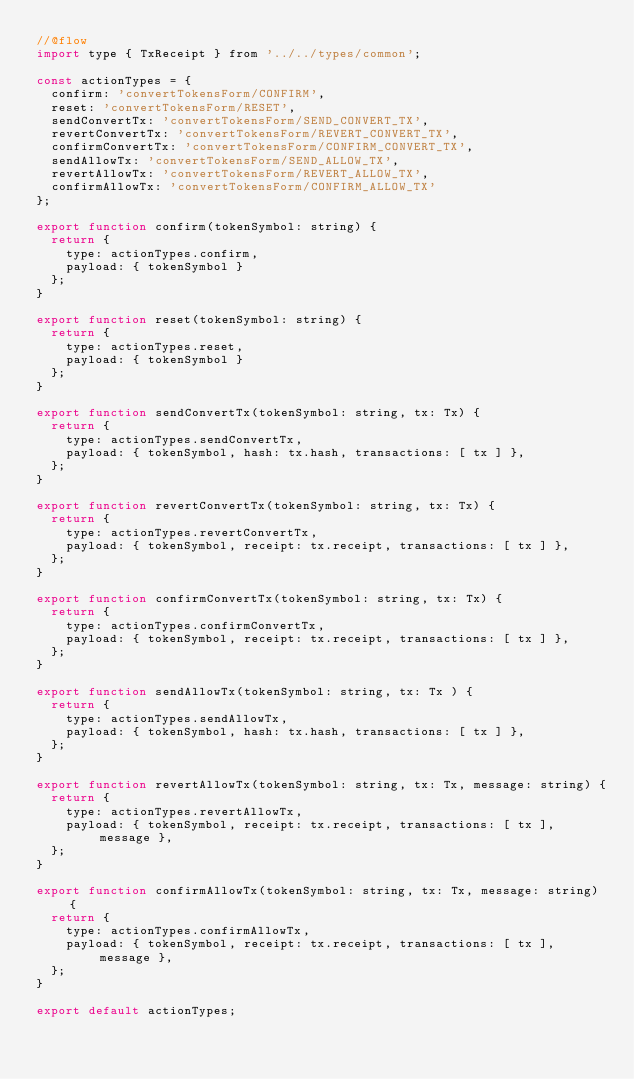<code> <loc_0><loc_0><loc_500><loc_500><_JavaScript_>//@flow
import type { TxReceipt } from '../../types/common';

const actionTypes = {
  confirm: 'convertTokensForm/CONFIRM',
  reset: 'convertTokensForm/RESET',
  sendConvertTx: 'convertTokensForm/SEND_CONVERT_TX',
  revertConvertTx: 'convertTokensForm/REVERT_CONVERT_TX',
  confirmConvertTx: 'convertTokensForm/CONFIRM_CONVERT_TX',
  sendAllowTx: 'convertTokensForm/SEND_ALLOW_TX',
  revertAllowTx: 'convertTokensForm/REVERT_ALLOW_TX',
  confirmAllowTx: 'convertTokensForm/CONFIRM_ALLOW_TX'
};

export function confirm(tokenSymbol: string) {
  return {
    type: actionTypes.confirm,
    payload: { tokenSymbol }
  };
}

export function reset(tokenSymbol: string) {
  return {
    type: actionTypes.reset,
    payload: { tokenSymbol }
  };
}

export function sendConvertTx(tokenSymbol: string, tx: Tx) {
  return {
    type: actionTypes.sendConvertTx,
    payload: { tokenSymbol, hash: tx.hash, transactions: [ tx ] },
  };
}

export function revertConvertTx(tokenSymbol: string, tx: Tx) {
  return {
    type: actionTypes.revertConvertTx,
    payload: { tokenSymbol, receipt: tx.receipt, transactions: [ tx ] },
  };
}

export function confirmConvertTx(tokenSymbol: string, tx: Tx) {
  return {
    type: actionTypes.confirmConvertTx,
    payload: { tokenSymbol, receipt: tx.receipt, transactions: [ tx ] },
  };
}

export function sendAllowTx(tokenSymbol: string, tx: Tx ) {
  return {
    type: actionTypes.sendAllowTx,
    payload: { tokenSymbol, hash: tx.hash, transactions: [ tx ] },
  };
}

export function revertAllowTx(tokenSymbol: string, tx: Tx, message: string) {
  return {
    type: actionTypes.revertAllowTx,
    payload: { tokenSymbol, receipt: tx.receipt, transactions: [ tx ], message },
  };
}

export function confirmAllowTx(tokenSymbol: string, tx: Tx, message: string) {
  return {
    type: actionTypes.confirmAllowTx,
    payload: { tokenSymbol, receipt: tx.receipt, transactions: [ tx ], message },
  };
}

export default actionTypes;
</code> 